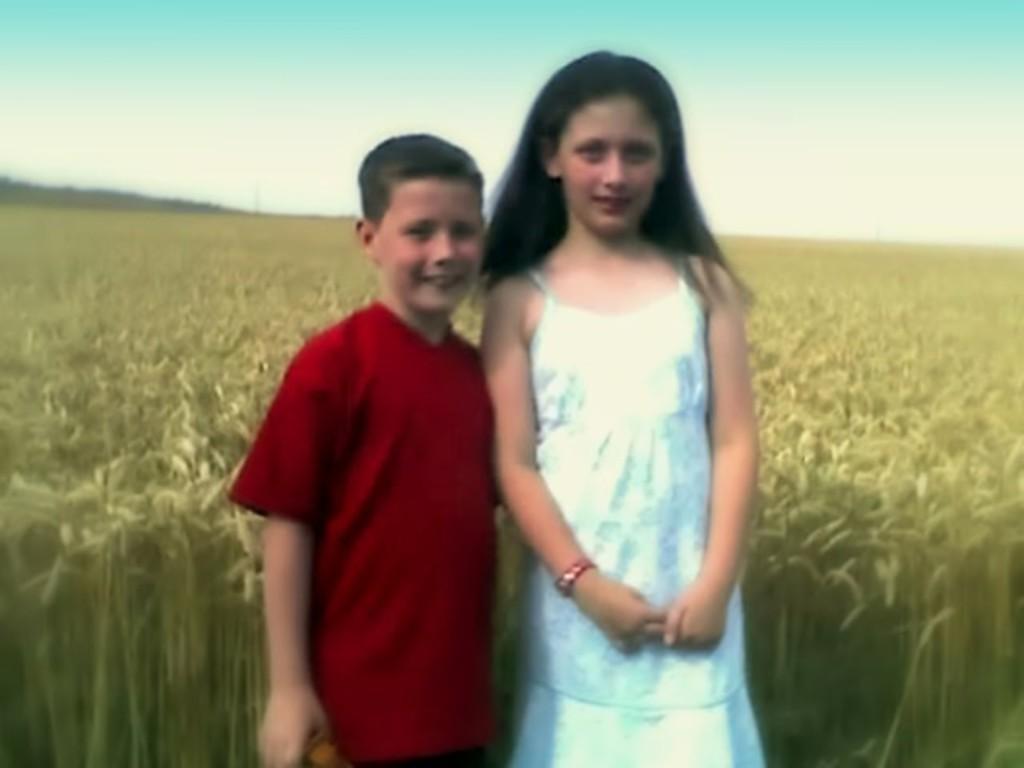In one or two sentences, can you explain what this image depicts? In the image in the center we can see two kids were standing and they were smiling,which we can see on their faces. In the background we can see the sky,clouds, and plants. 